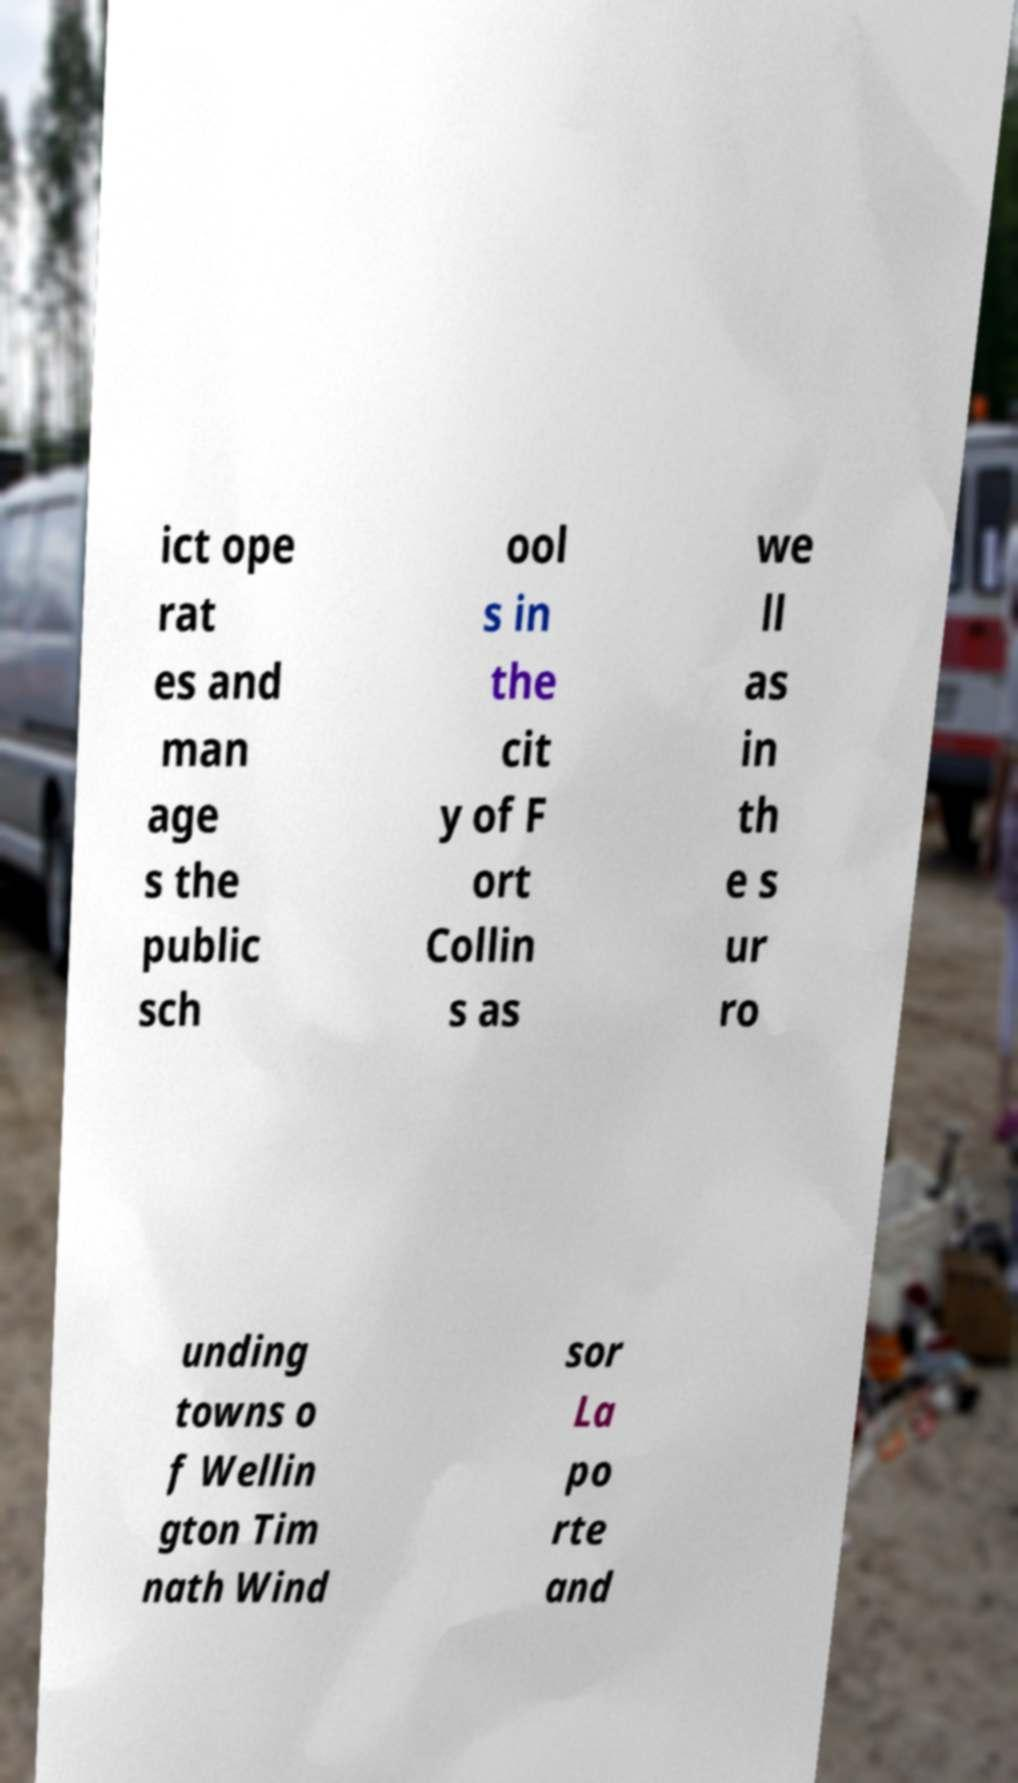I need the written content from this picture converted into text. Can you do that? ict ope rat es and man age s the public sch ool s in the cit y of F ort Collin s as we ll as in th e s ur ro unding towns o f Wellin gton Tim nath Wind sor La po rte and 